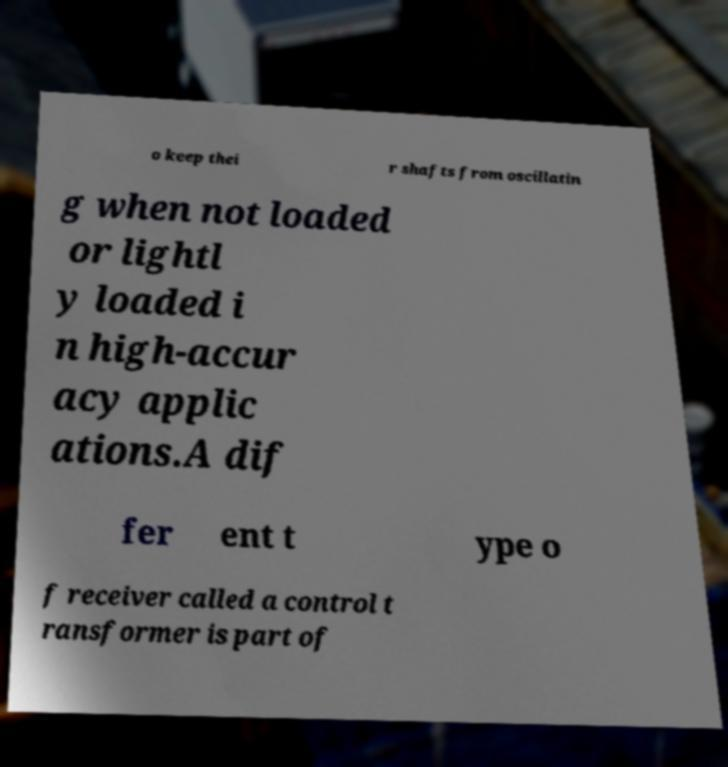Can you accurately transcribe the text from the provided image for me? o keep thei r shafts from oscillatin g when not loaded or lightl y loaded i n high-accur acy applic ations.A dif fer ent t ype o f receiver called a control t ransformer is part of 